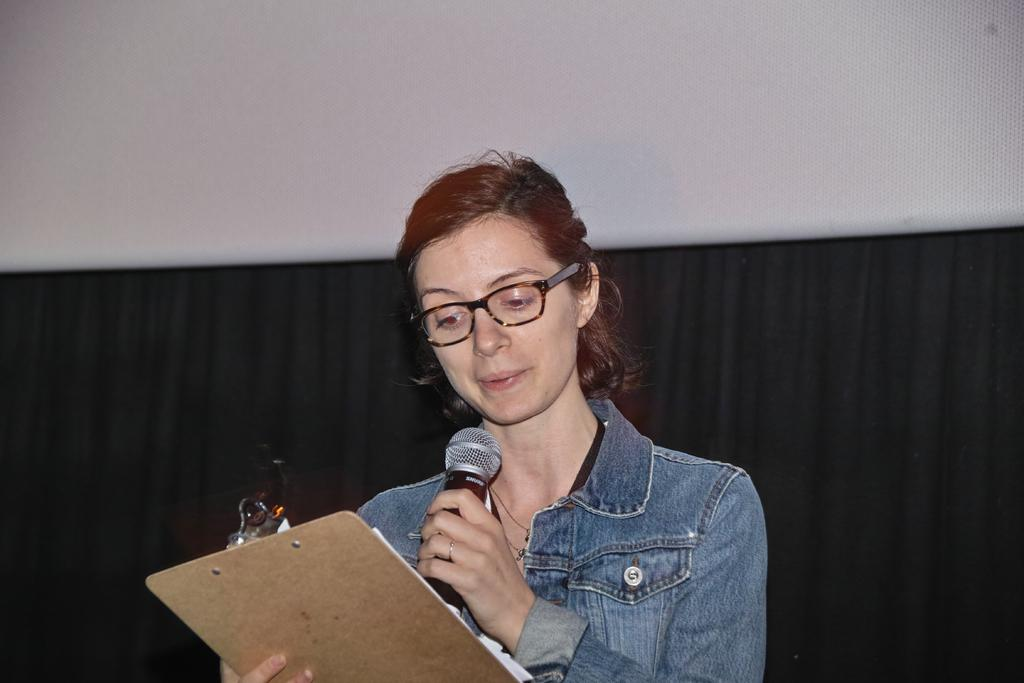What is the main subject of the image? There is a woman in the image. What is the woman doing in the image? The woman is standing and holding a plank and a mic. What can be seen in the background of the image? There is a curtain in the background of the image. How is the curtain attached in the image? The curtain is attached to a wall. What type of joke is the woman telling in the image? There is no indication in the image that the woman is telling a joke, so it cannot be determined from the picture. 